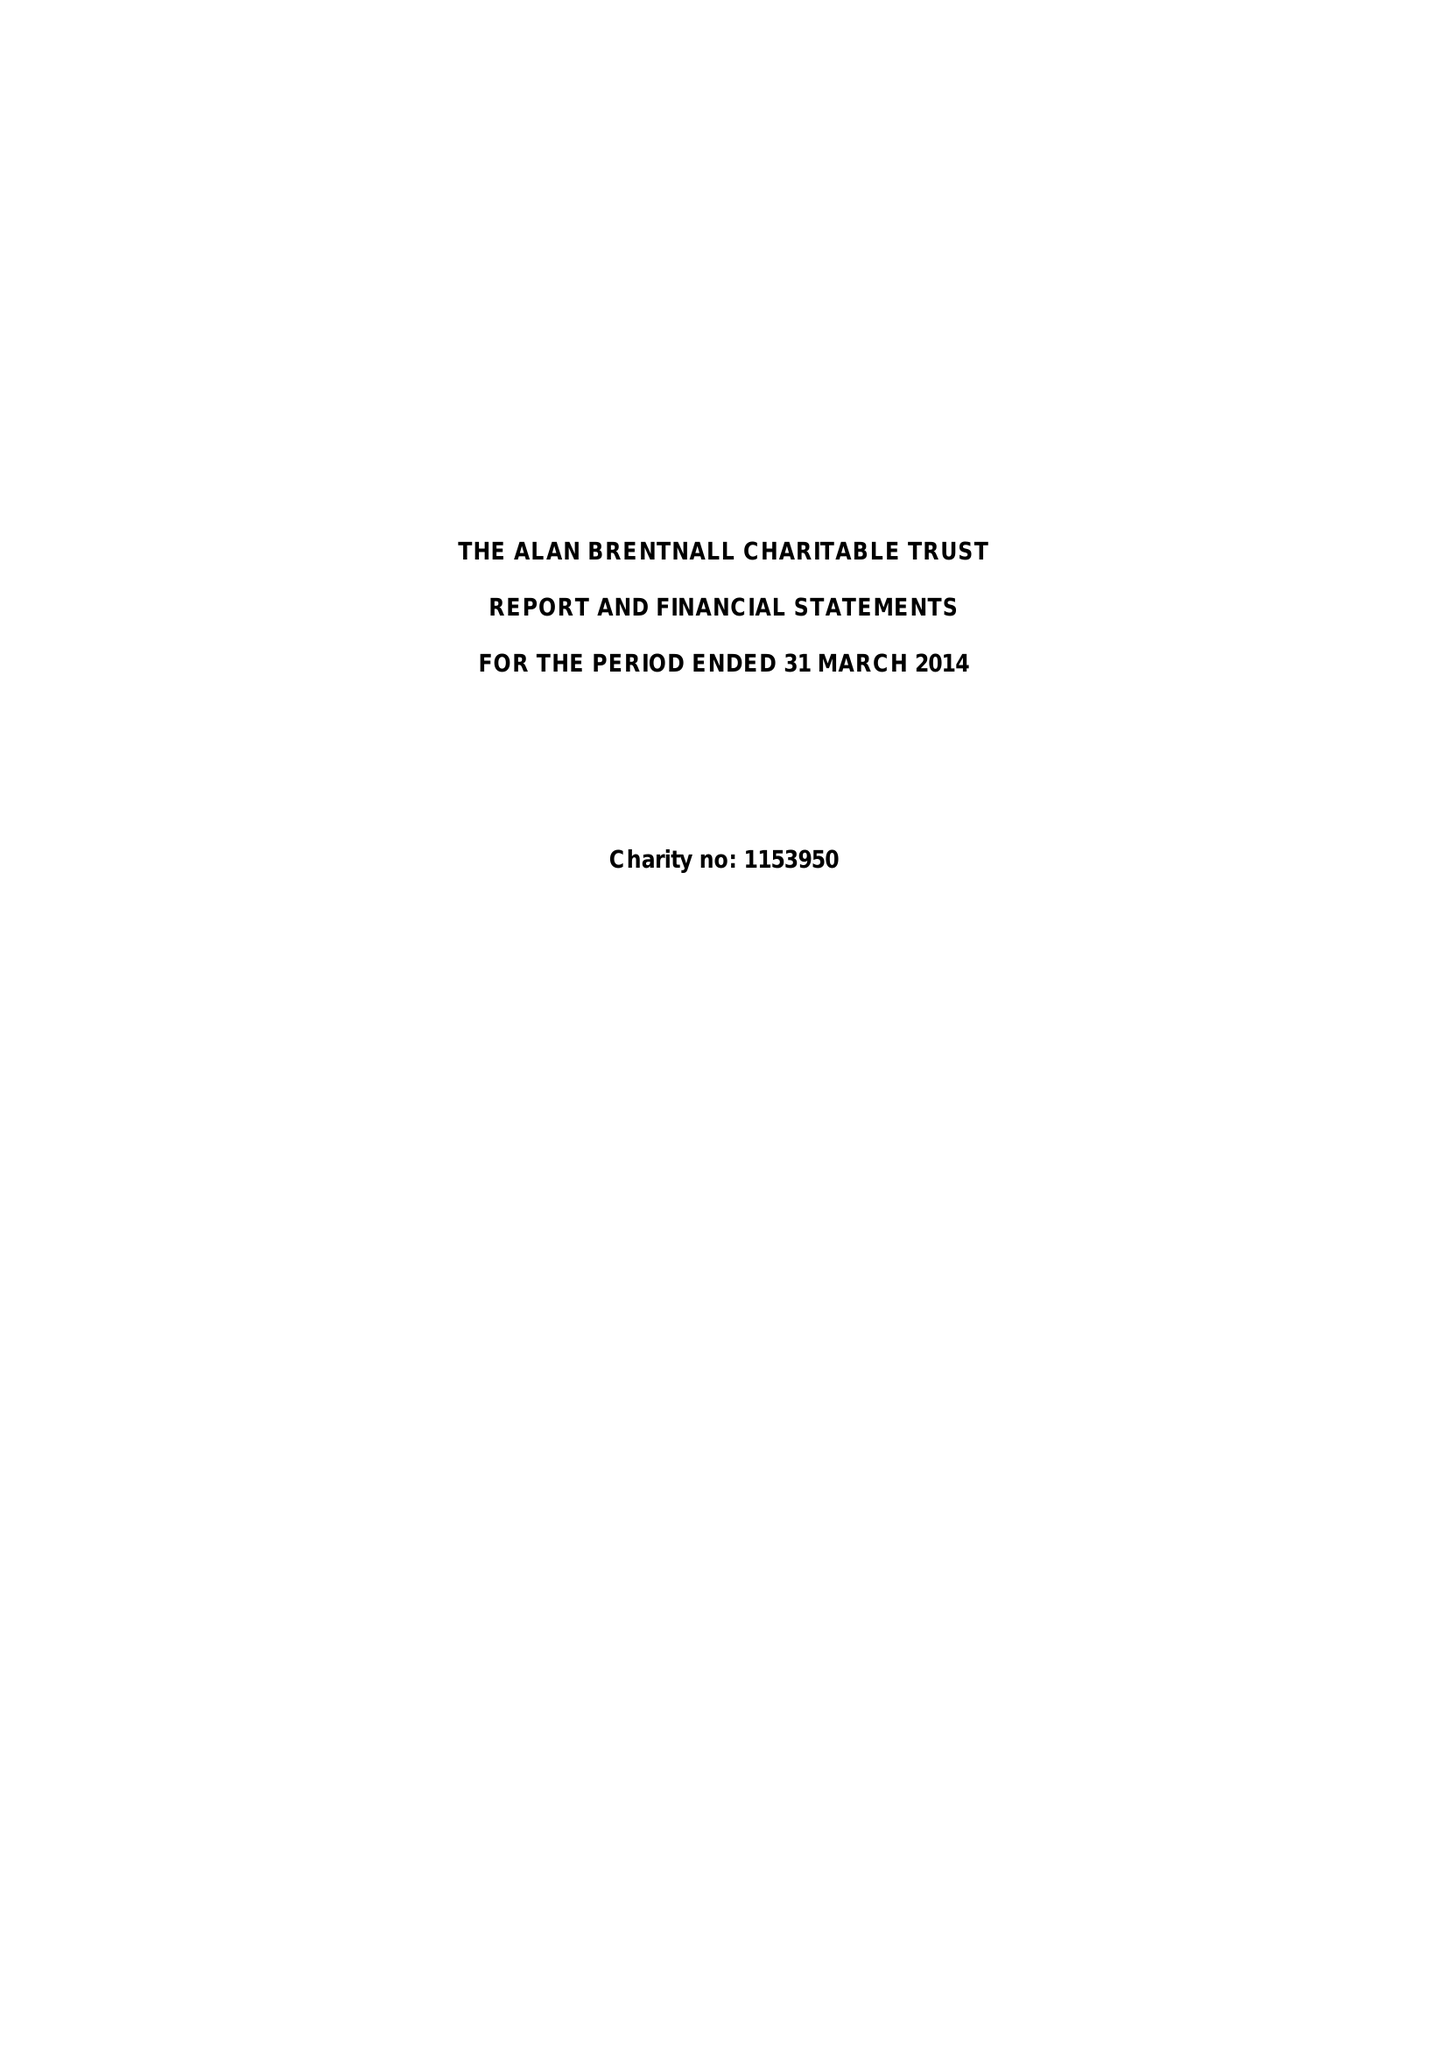What is the value for the spending_annually_in_british_pounds?
Answer the question using a single word or phrase. 19895.00 